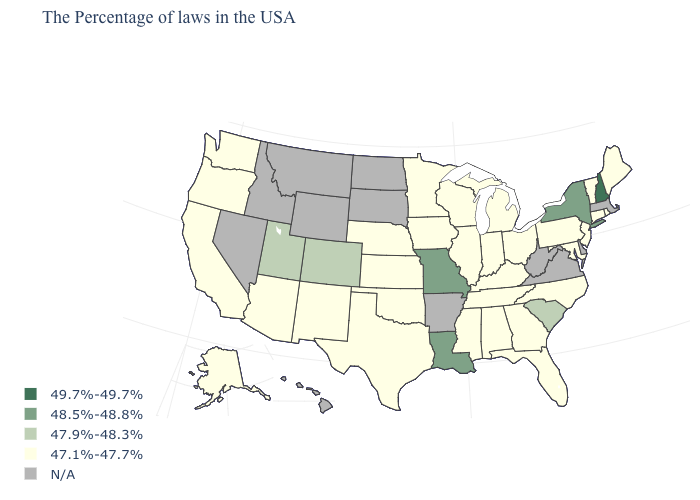How many symbols are there in the legend?
Keep it brief. 5. What is the value of New Hampshire?
Quick response, please. 49.7%-49.7%. Name the states that have a value in the range N/A?
Write a very short answer. Massachusetts, Delaware, Virginia, West Virginia, Arkansas, South Dakota, North Dakota, Wyoming, Montana, Idaho, Nevada, Hawaii. Does the first symbol in the legend represent the smallest category?
Give a very brief answer. No. What is the value of Indiana?
Write a very short answer. 47.1%-47.7%. Name the states that have a value in the range N/A?
Be succinct. Massachusetts, Delaware, Virginia, West Virginia, Arkansas, South Dakota, North Dakota, Wyoming, Montana, Idaho, Nevada, Hawaii. Name the states that have a value in the range 48.5%-48.8%?
Give a very brief answer. New York, Louisiana, Missouri. What is the value of New Hampshire?
Quick response, please. 49.7%-49.7%. What is the lowest value in the Northeast?
Give a very brief answer. 47.1%-47.7%. What is the lowest value in the USA?
Short answer required. 47.1%-47.7%. What is the value of Connecticut?
Give a very brief answer. 47.1%-47.7%. What is the lowest value in states that border Minnesota?
Write a very short answer. 47.1%-47.7%. What is the value of Colorado?
Write a very short answer. 47.9%-48.3%. 